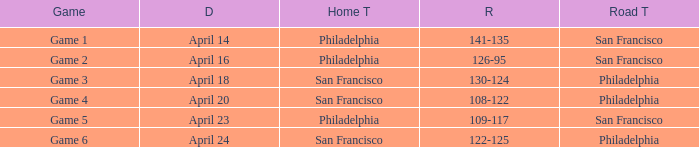What was the result of the April 16 game? 126-95. 